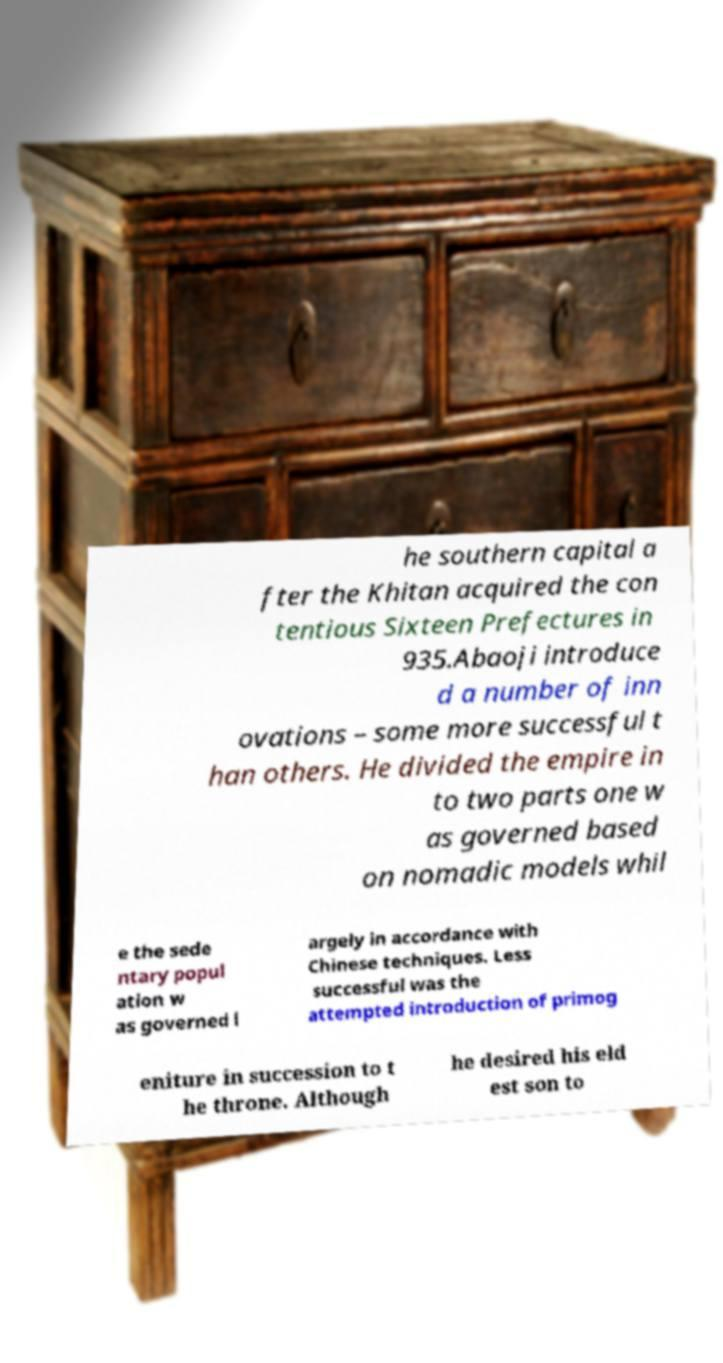Could you assist in decoding the text presented in this image and type it out clearly? he southern capital a fter the Khitan acquired the con tentious Sixteen Prefectures in 935.Abaoji introduce d a number of inn ovations – some more successful t han others. He divided the empire in to two parts one w as governed based on nomadic models whil e the sede ntary popul ation w as governed l argely in accordance with Chinese techniques. Less successful was the attempted introduction of primog eniture in succession to t he throne. Although he desired his eld est son to 